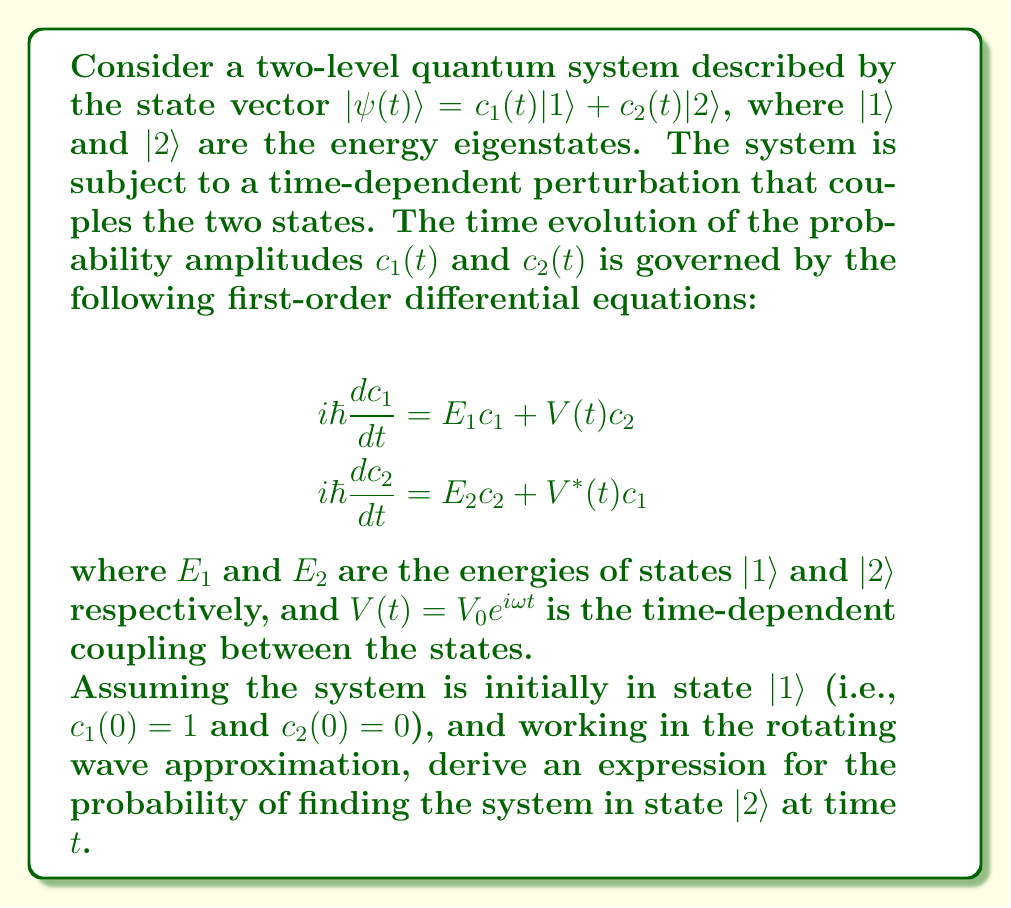Help me with this question. Let's approach this step-by-step:

1) First, we'll transform to the interaction picture by defining:
   $$c_1(t) = \tilde{c}_1(t)e^{-iE_1t/\hbar}$$
   $$c_2(t) = \tilde{c}_2(t)e^{-iE_2t/\hbar}$$

2) Substituting these into the original equations and using the rotating wave approximation (neglecting rapidly oscillating terms), we get:

   $$i\hbar\frac{d\tilde{c}_1}{dt} = V_0\tilde{c}_2e^{i\Delta t}$$
   $$i\hbar\frac{d\tilde{c}_2}{dt} = V_0\tilde{c}_1e^{-i\Delta t}$$

   where $\Delta = (E_2 - E_1)/\hbar - \omega$

3) Differentiating the second equation and substituting the first:

   $$\frac{d^2\tilde{c}_2}{dt^2} + i\Delta\frac{d\tilde{c}_2}{dt} + \frac{|V_0|^2}{\hbar^2}\tilde{c}_2 = 0$$

4) This is a second-order differential equation with constant coefficients. The general solution is:

   $$\tilde{c}_2(t) = Ae^{i\lambda_1t} + Be^{i\lambda_2t}$$

   where $\lambda_{1,2} = -\frac{\Delta}{2} \pm \sqrt{\frac{\Delta^2}{4} + \frac{|V_0|^2}{\hbar^2}}$

5) Using the initial conditions $c_2(0) = 0$ and $\frac{dc_2}{dt}(0) = -\frac{iV_0}{\hbar}$, we can determine A and B:

   $$A = -B = \frac{iV_0}{2\hbar\sqrt{\frac{\Delta^2}{4} + \frac{|V_0|^2}{\hbar^2}}}$$

6) Therefore, the solution for $\tilde{c}_2(t)$ is:

   $$\tilde{c}_2(t) = \frac{iV_0}{2\hbar\sqrt{\frac{\Delta^2}{4} + \frac{|V_0|^2}{\hbar^2}}}(e^{i\lambda_1t} - e^{i\lambda_2t})$$

7) The probability of finding the system in state $|2\rangle$ at time $t$ is $|c_2(t)|^2 = |\tilde{c}_2(t)|^2$:

   $$P_2(t) = \frac{|V_0|^2}{\hbar^2(\frac{\Delta^2}{4} + \frac{|V_0|^2}{\hbar^2})}\sin^2\left(\sqrt{\frac{\Delta^2}{4} + \frac{|V_0|^2}{\hbar^2}}t\right)$$

This is the final expression for the probability as a function of time.
Answer: $$P_2(t) = \frac{|V_0|^2}{\hbar^2(\frac{\Delta^2}{4} + \frac{|V_0|^2}{\hbar^2})}\sin^2\left(\sqrt{\frac{\Delta^2}{4} + \frac{|V_0|^2}{\hbar^2}}t\right)$$ 